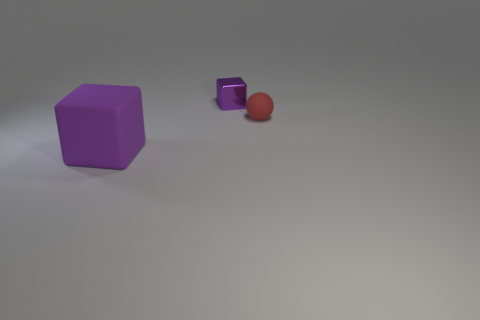There is a purple object behind the matte block; is it the same shape as the large rubber thing?
Ensure brevity in your answer.  Yes. Are there fewer tiny purple things that are in front of the tiny red rubber object than large things in front of the large block?
Offer a very short reply. No. What material is the tiny cube?
Keep it short and to the point. Metal. Is the color of the small block the same as the matte thing on the left side of the tiny metallic block?
Your answer should be very brief. Yes. There is a large rubber cube; what number of things are behind it?
Provide a short and direct response. 2. Are there fewer tiny shiny blocks on the right side of the small shiny thing than tiny rubber objects?
Provide a short and direct response. Yes. The tiny rubber ball has what color?
Your answer should be very brief. Red. Do the matte thing behind the purple matte object and the tiny cube have the same color?
Keep it short and to the point. No. What color is the tiny object that is the same shape as the big purple thing?
Offer a terse response. Purple. How many small objects are red rubber things or shiny objects?
Ensure brevity in your answer.  2. 